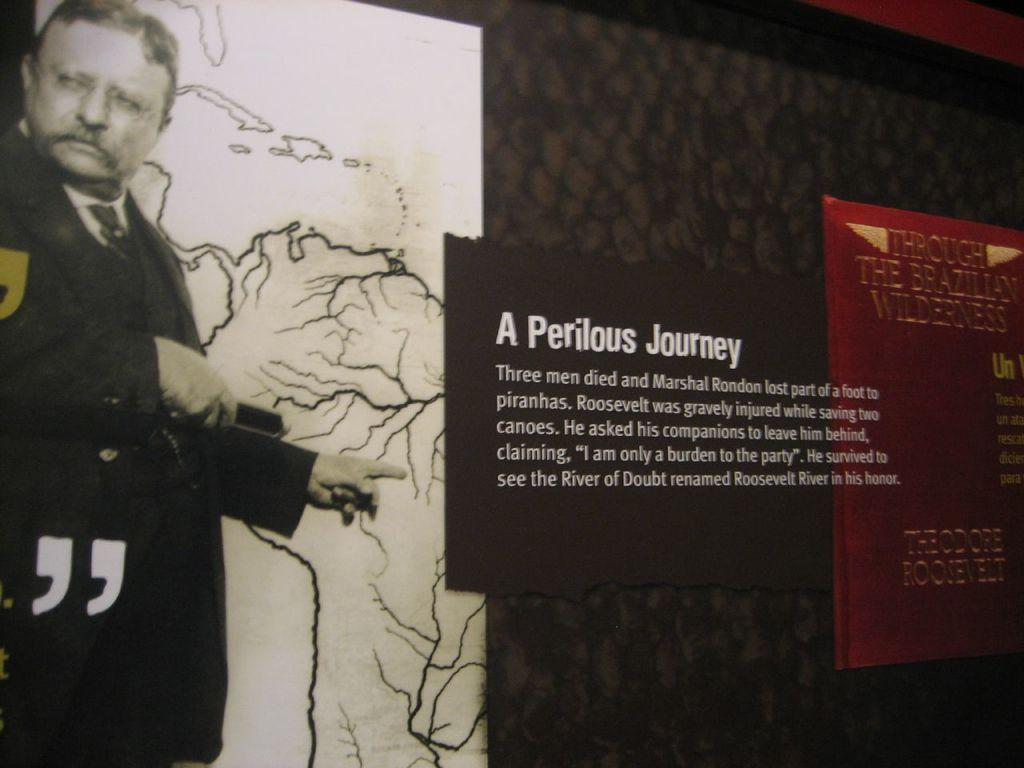<image>
Present a compact description of the photo's key features. A display with a man pointing to a sign that talks about A Perilous Journey. 